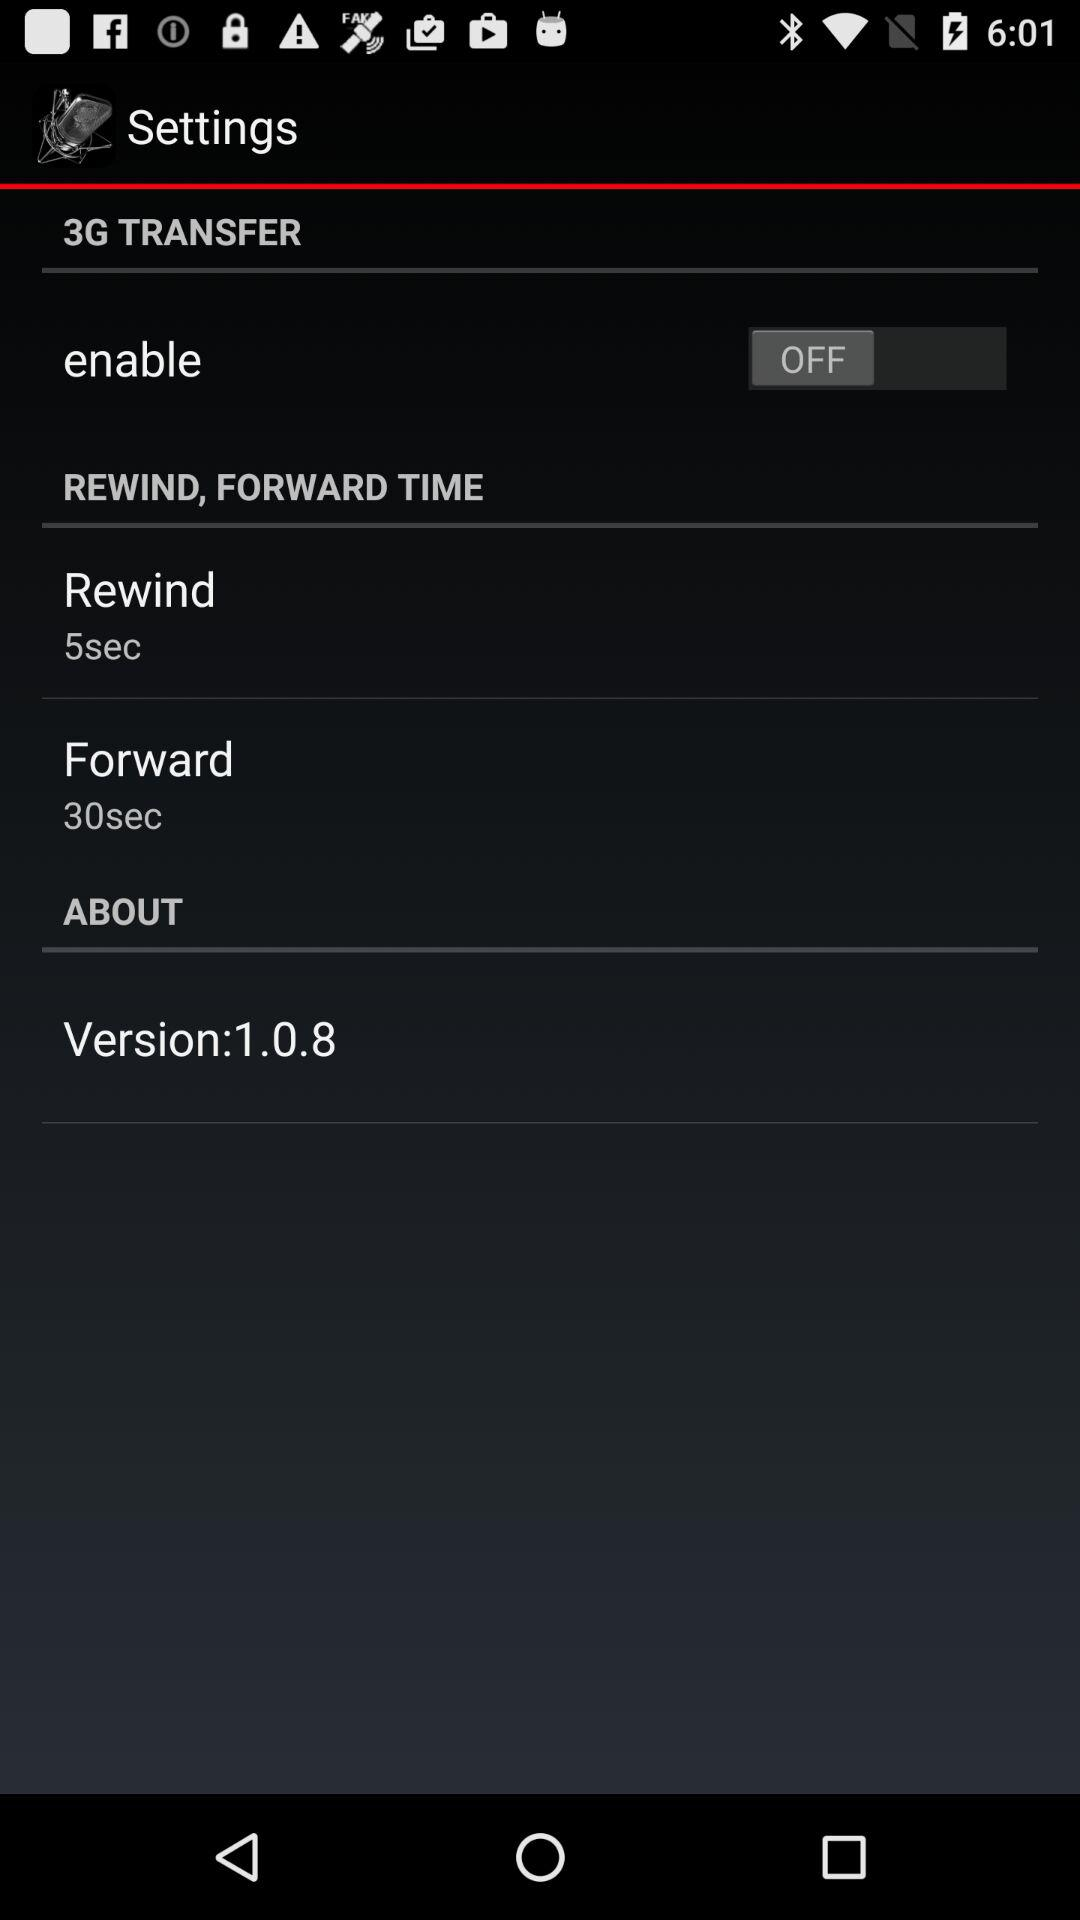What is the selected "Forward" time? The "Forward" time is 30 seconds. 